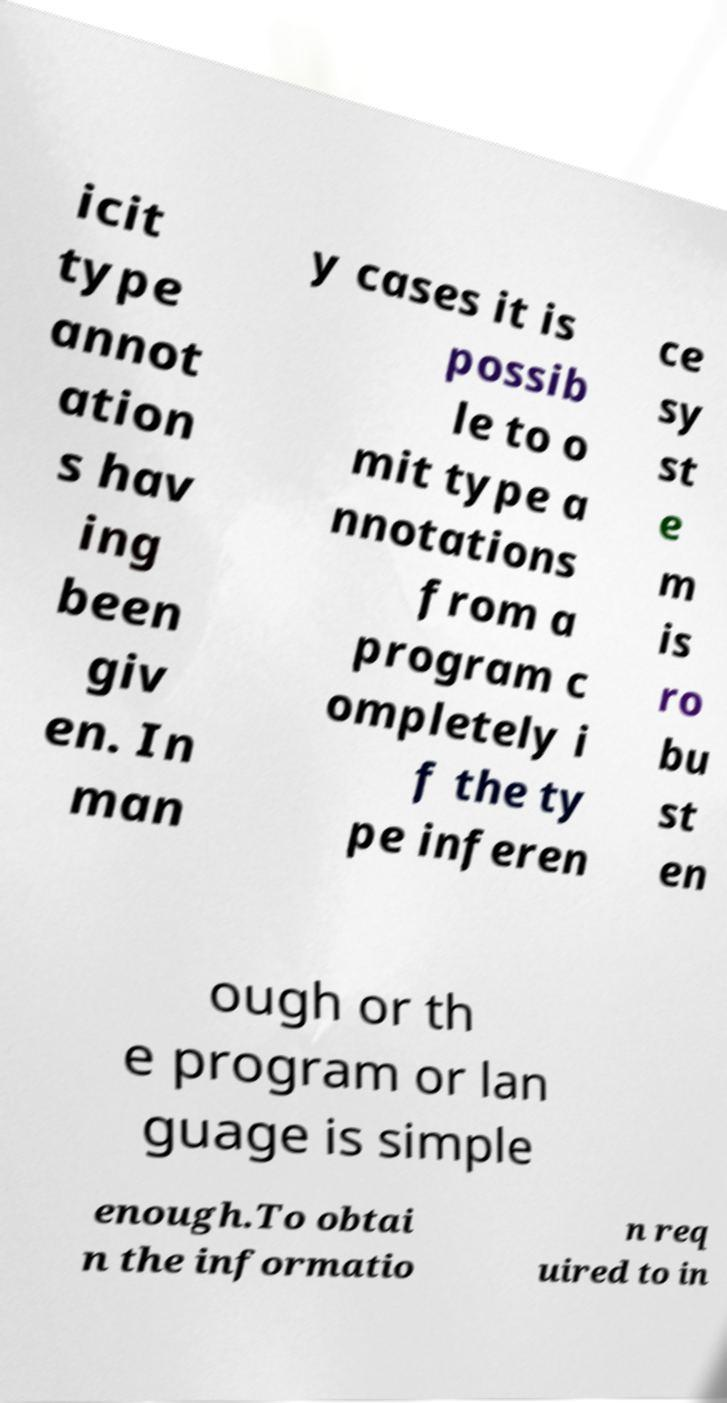What messages or text are displayed in this image? I need them in a readable, typed format. icit type annot ation s hav ing been giv en. In man y cases it is possib le to o mit type a nnotations from a program c ompletely i f the ty pe inferen ce sy st e m is ro bu st en ough or th e program or lan guage is simple enough.To obtai n the informatio n req uired to in 